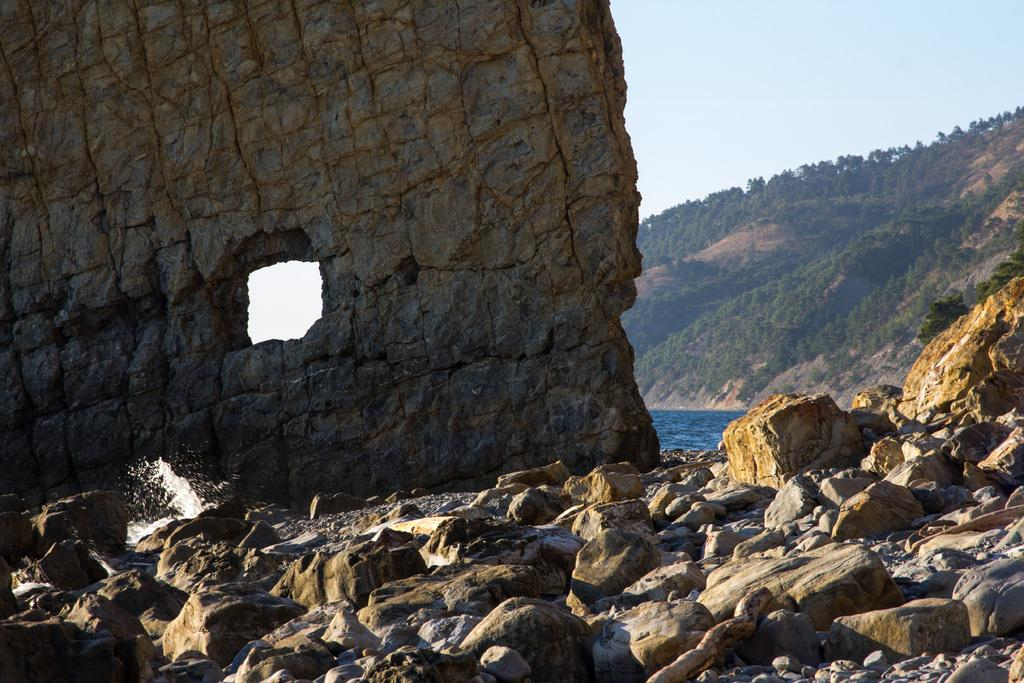What is the main feature of the image? There are many stones in the image. What structure is made of stones in the image? There is a stone wall in the image. What can be seen behind the stone wall? There is water visible behind the wall. What is located at the right side of the image? There is a mountain at the right side of the image. What type of vegetation is present on the mountain? There are trees on the mountain. How many eggs are present on the mountain in the image? There are no eggs present in the image; it features stones, a stone wall, water, a mountain, and trees. 